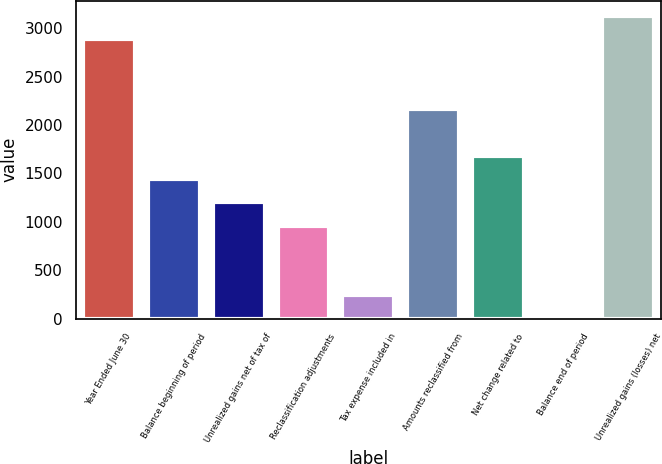Convert chart to OTSL. <chart><loc_0><loc_0><loc_500><loc_500><bar_chart><fcel>Year Ended June 30<fcel>Balance beginning of period<fcel>Unrealized gains net of tax of<fcel>Reclassification adjustments<fcel>Tax expense included in<fcel>Amounts reclassified from<fcel>Net change related to<fcel>Balance end of period<fcel>Unrealized gains (losses) net<nl><fcel>2885.6<fcel>1443.92<fcel>1203.64<fcel>963.36<fcel>242.52<fcel>2164.76<fcel>1684.2<fcel>2.24<fcel>3125.88<nl></chart> 